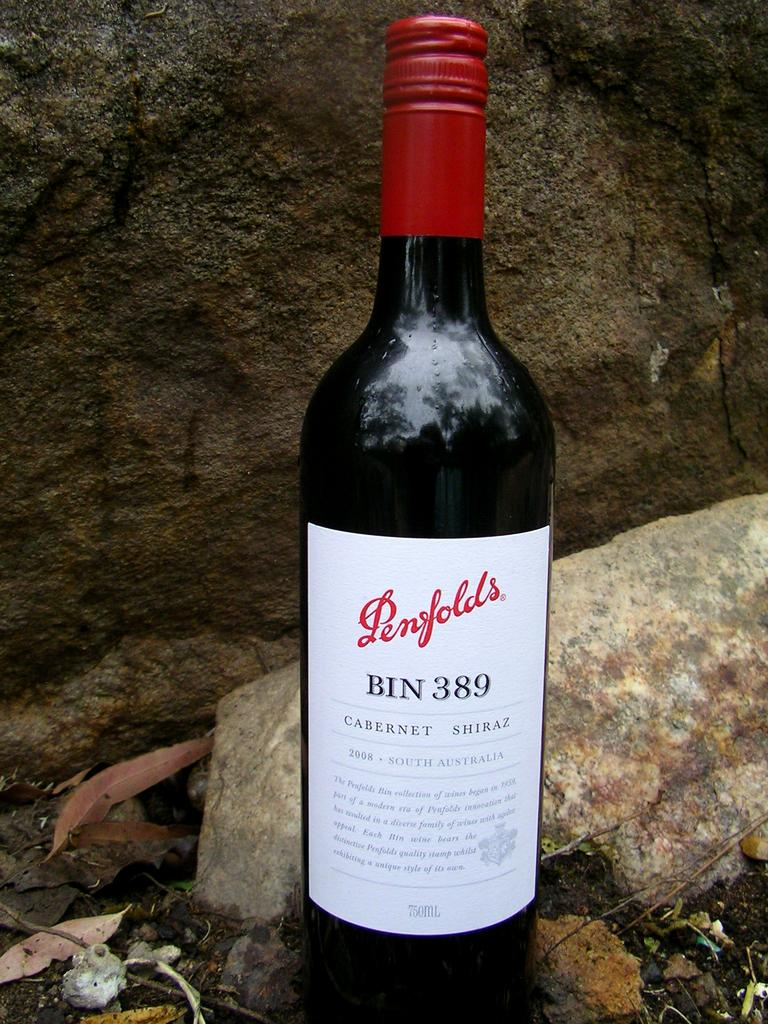<image>
Give a short and clear explanation of the subsequent image. A loan bottle of Renfolds BIN 389 near some rocks. 